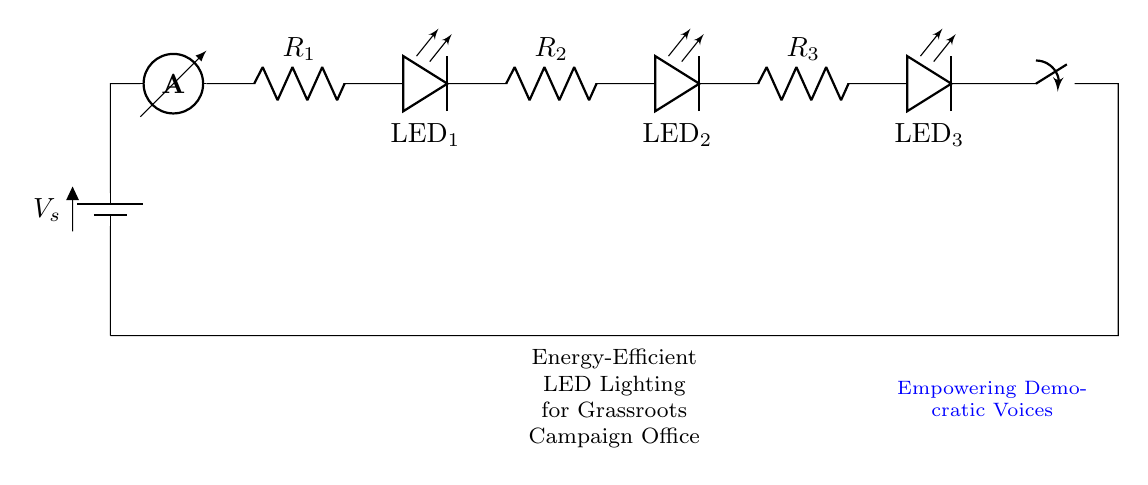What is the total number of LEDs in this circuit? There are three LEDs indicated in the diagram, labeled as LED_1, LED_2, and LED_3, connected in series.
Answer: 3 What does the battery represent in this circuit? The battery, labeled as Vs, represents the voltage source supplying electricity to the circuit, making it the source of power.
Answer: Voltage source What type of circuit is used in this diagram? The circuit uses a series configuration as all components, including resistors and LEDs, are connected in a single path, leading to a continuous flow of current.
Answer: Series What happens if one LED fails in this circuit? If one LED fails, the series circuit would break, causing the current to stop and all LEDs to turn off because they depend on a single path for current flow.
Answer: All LEDs off What component is responsible for limiting current in this circuit? The resistors, labeled as R_1, R_2, and R_3, are responsible for limiting the current flowing through the LEDs, ensuring they operate safely without burning out.
Answer: Resistors How many resistors are present in this circuit? There are three resistors present in the diagram, each connected in series with the LEDs to limit the current through them.
Answer: 3 